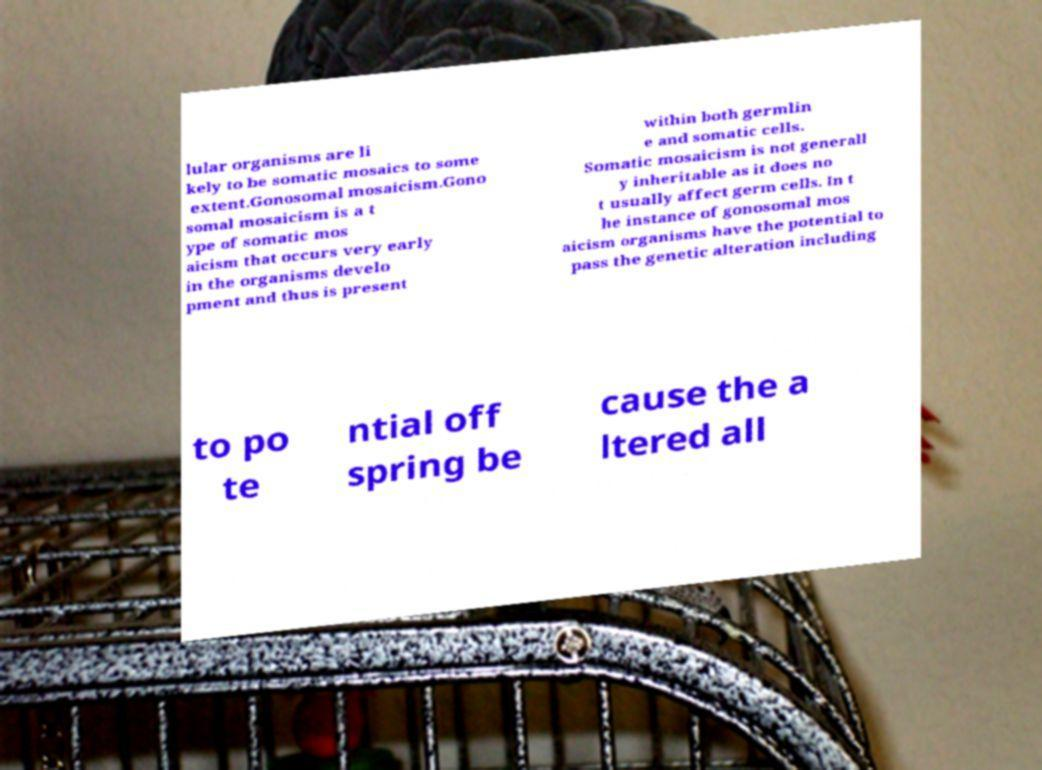Could you extract and type out the text from this image? lular organisms are li kely to be somatic mosaics to some extent.Gonosomal mosaicism.Gono somal mosaicism is a t ype of somatic mos aicism that occurs very early in the organisms develo pment and thus is present within both germlin e and somatic cells. Somatic mosaicism is not generall y inheritable as it does no t usually affect germ cells. In t he instance of gonosomal mos aicism organisms have the potential to pass the genetic alteration including to po te ntial off spring be cause the a ltered all 